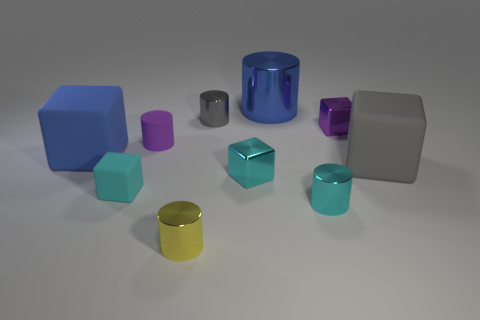Is the size of the blue metal cylinder the same as the gray shiny object behind the large gray rubber cube? The blue metal cylinder appears to be larger in height and diameter compared to the small gray shiny object positioned behind the large gray cube. 